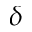Convert formula to latex. <formula><loc_0><loc_0><loc_500><loc_500>\delta</formula> 